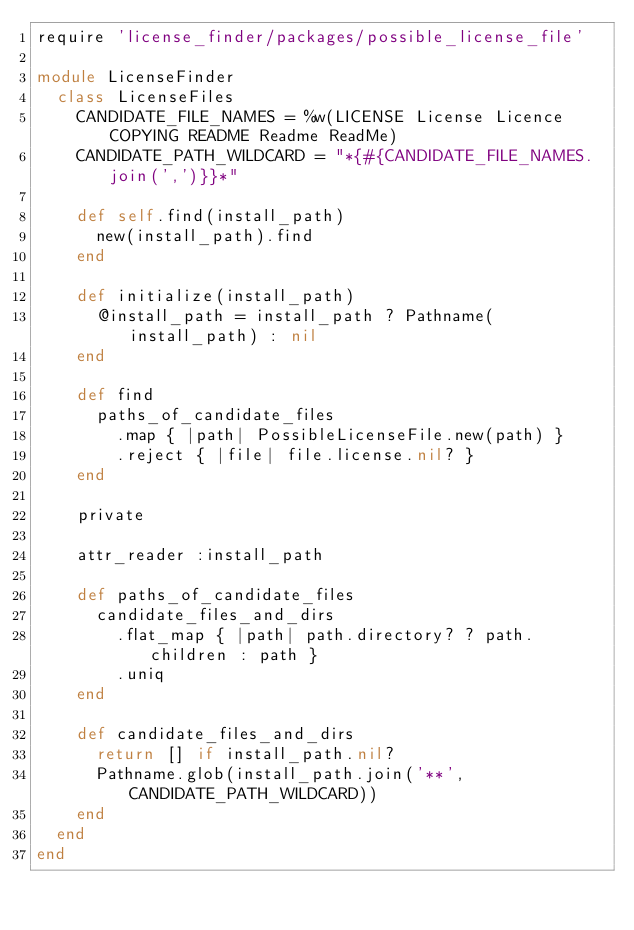<code> <loc_0><loc_0><loc_500><loc_500><_Ruby_>require 'license_finder/packages/possible_license_file'

module LicenseFinder
  class LicenseFiles
    CANDIDATE_FILE_NAMES = %w(LICENSE License Licence COPYING README Readme ReadMe)
    CANDIDATE_PATH_WILDCARD = "*{#{CANDIDATE_FILE_NAMES.join(',')}}*"

    def self.find(install_path)
      new(install_path).find
    end

    def initialize(install_path)
      @install_path = install_path ? Pathname(install_path) : nil
    end

    def find
      paths_of_candidate_files
        .map { |path| PossibleLicenseFile.new(path) }
        .reject { |file| file.license.nil? }
    end

    private

    attr_reader :install_path

    def paths_of_candidate_files
      candidate_files_and_dirs
        .flat_map { |path| path.directory? ? path.children : path }
        .uniq
    end

    def candidate_files_and_dirs
      return [] if install_path.nil?
      Pathname.glob(install_path.join('**', CANDIDATE_PATH_WILDCARD))
    end
  end
end
</code> 